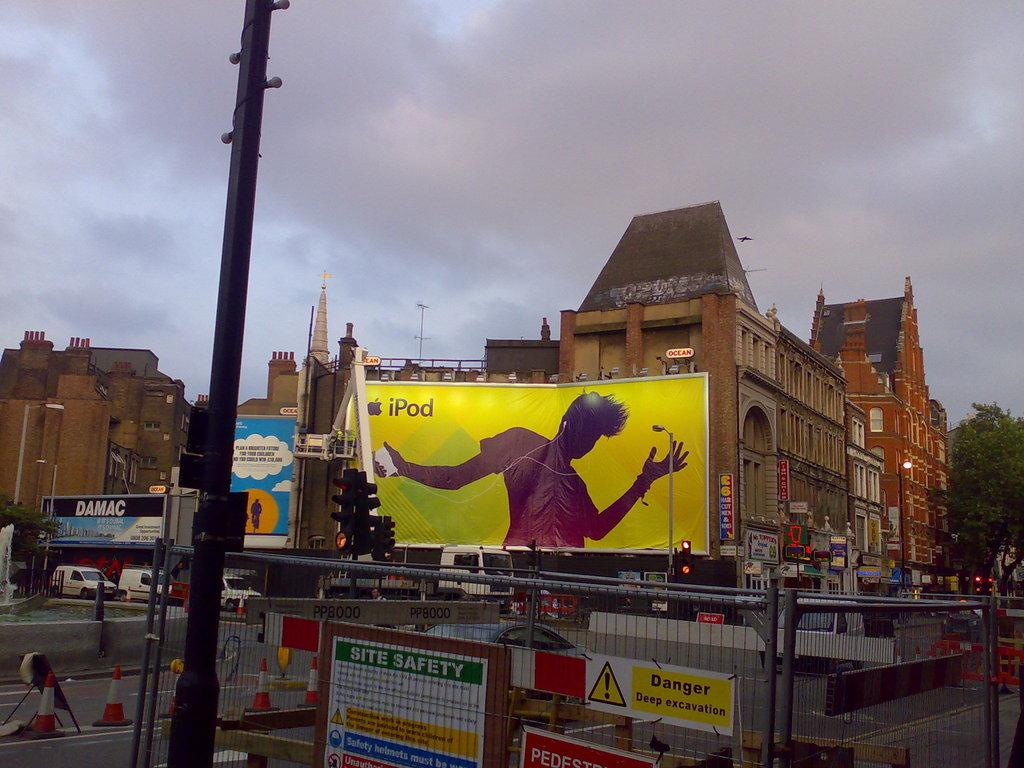<image>
Share a concise interpretation of the image provided. an ipod advertisement is hanging on a building 